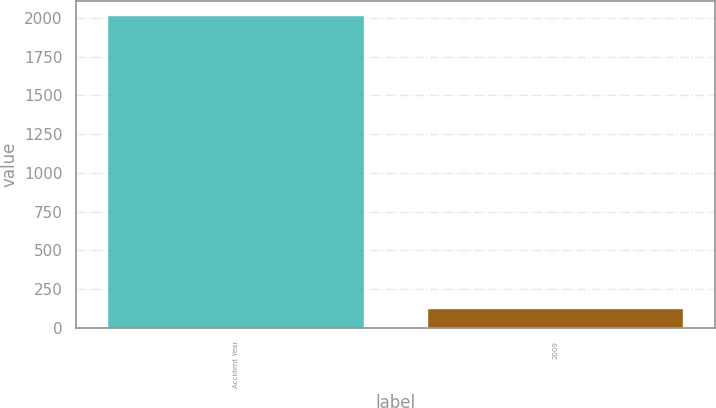<chart> <loc_0><loc_0><loc_500><loc_500><bar_chart><fcel>Accident Year<fcel>2009<nl><fcel>2011<fcel>124<nl></chart> 